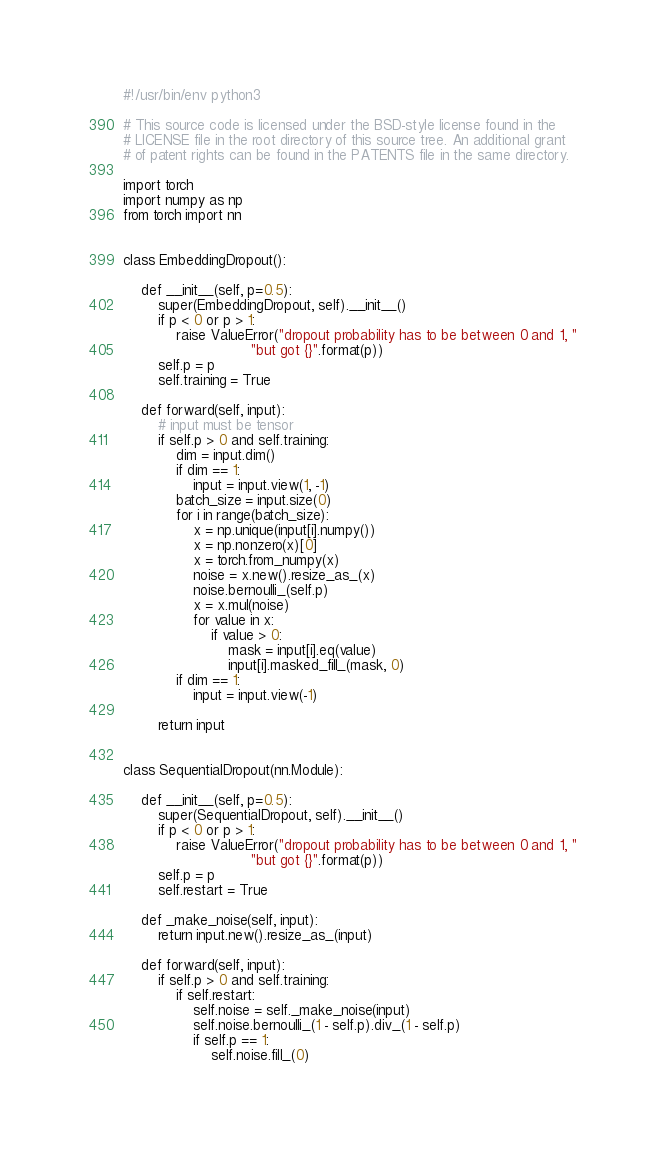<code> <loc_0><loc_0><loc_500><loc_500><_Python_>#!/usr/bin/env python3

# This source code is licensed under the BSD-style license found in the
# LICENSE file in the root directory of this source tree. An additional grant
# of patent rights can be found in the PATENTS file in the same directory.

import torch
import numpy as np
from torch import nn


class EmbeddingDropout():

    def __init__(self, p=0.5):
        super(EmbeddingDropout, self).__init__()
        if p < 0 or p > 1:
            raise ValueError("dropout probability has to be between 0 and 1, "
                             "but got {}".format(p))
        self.p = p
        self.training = True

    def forward(self, input):
        # input must be tensor
        if self.p > 0 and self.training:
            dim = input.dim()
            if dim == 1:
                input = input.view(1, -1)
            batch_size = input.size(0)
            for i in range(batch_size):
                x = np.unique(input[i].numpy())
                x = np.nonzero(x)[0]
                x = torch.from_numpy(x)
                noise = x.new().resize_as_(x)
                noise.bernoulli_(self.p)
                x = x.mul(noise)
                for value in x:
                    if value > 0:
                        mask = input[i].eq(value)
                        input[i].masked_fill_(mask, 0)
            if dim == 1:
                input = input.view(-1)

        return input


class SequentialDropout(nn.Module):

    def __init__(self, p=0.5):
        super(SequentialDropout, self).__init__()
        if p < 0 or p > 1:
            raise ValueError("dropout probability has to be between 0 and 1, "
                             "but got {}".format(p))
        self.p = p
        self.restart = True

    def _make_noise(self, input):
        return input.new().resize_as_(input)

    def forward(self, input):
        if self.p > 0 and self.training:
            if self.restart:
                self.noise = self._make_noise(input)
                self.noise.bernoulli_(1 - self.p).div_(1 - self.p)
                if self.p == 1:
                    self.noise.fill_(0)</code> 